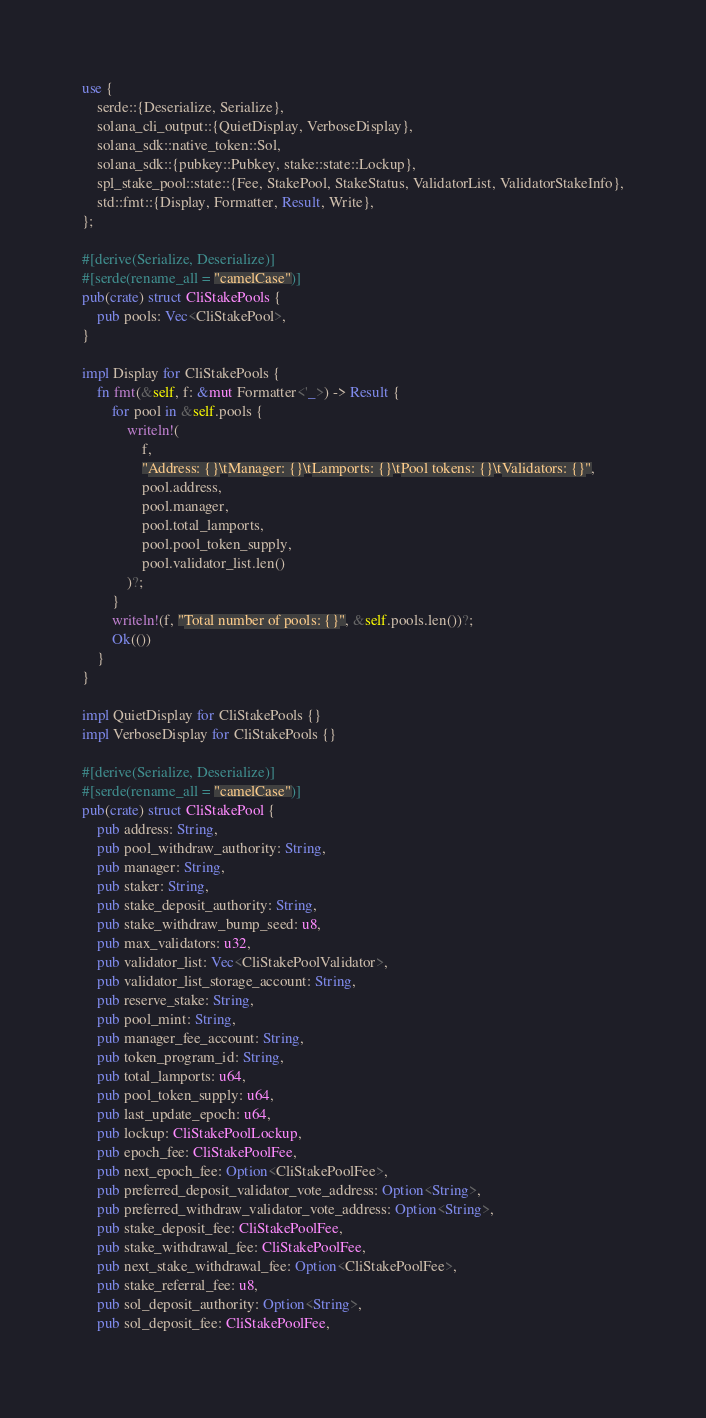<code> <loc_0><loc_0><loc_500><loc_500><_Rust_>use {
    serde::{Deserialize, Serialize},
    solana_cli_output::{QuietDisplay, VerboseDisplay},
    solana_sdk::native_token::Sol,
    solana_sdk::{pubkey::Pubkey, stake::state::Lockup},
    spl_stake_pool::state::{Fee, StakePool, StakeStatus, ValidatorList, ValidatorStakeInfo},
    std::fmt::{Display, Formatter, Result, Write},
};

#[derive(Serialize, Deserialize)]
#[serde(rename_all = "camelCase")]
pub(crate) struct CliStakePools {
    pub pools: Vec<CliStakePool>,
}

impl Display for CliStakePools {
    fn fmt(&self, f: &mut Formatter<'_>) -> Result {
        for pool in &self.pools {
            writeln!(
                f,
                "Address: {}\tManager: {}\tLamports: {}\tPool tokens: {}\tValidators: {}",
                pool.address,
                pool.manager,
                pool.total_lamports,
                pool.pool_token_supply,
                pool.validator_list.len()
            )?;
        }
        writeln!(f, "Total number of pools: {}", &self.pools.len())?;
        Ok(())
    }
}

impl QuietDisplay for CliStakePools {}
impl VerboseDisplay for CliStakePools {}

#[derive(Serialize, Deserialize)]
#[serde(rename_all = "camelCase")]
pub(crate) struct CliStakePool {
    pub address: String,
    pub pool_withdraw_authority: String,
    pub manager: String,
    pub staker: String,
    pub stake_deposit_authority: String,
    pub stake_withdraw_bump_seed: u8,
    pub max_validators: u32,
    pub validator_list: Vec<CliStakePoolValidator>,
    pub validator_list_storage_account: String,
    pub reserve_stake: String,
    pub pool_mint: String,
    pub manager_fee_account: String,
    pub token_program_id: String,
    pub total_lamports: u64,
    pub pool_token_supply: u64,
    pub last_update_epoch: u64,
    pub lockup: CliStakePoolLockup,
    pub epoch_fee: CliStakePoolFee,
    pub next_epoch_fee: Option<CliStakePoolFee>,
    pub preferred_deposit_validator_vote_address: Option<String>,
    pub preferred_withdraw_validator_vote_address: Option<String>,
    pub stake_deposit_fee: CliStakePoolFee,
    pub stake_withdrawal_fee: CliStakePoolFee,
    pub next_stake_withdrawal_fee: Option<CliStakePoolFee>,
    pub stake_referral_fee: u8,
    pub sol_deposit_authority: Option<String>,
    pub sol_deposit_fee: CliStakePoolFee,</code> 